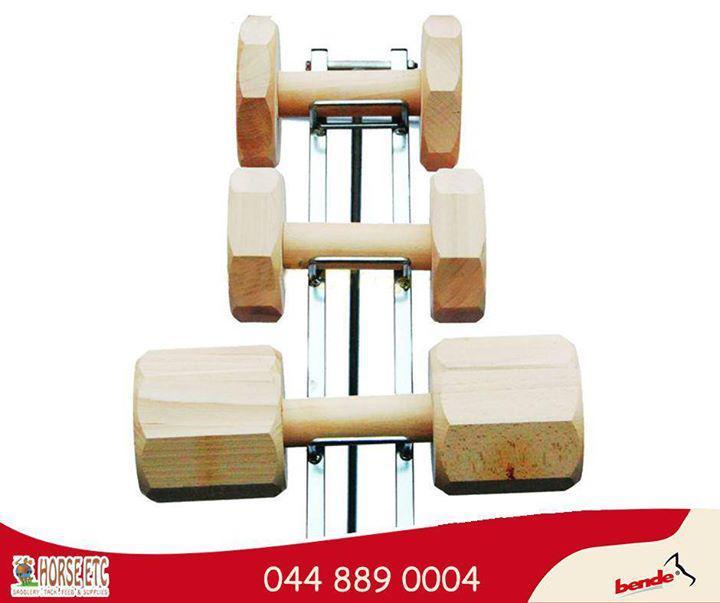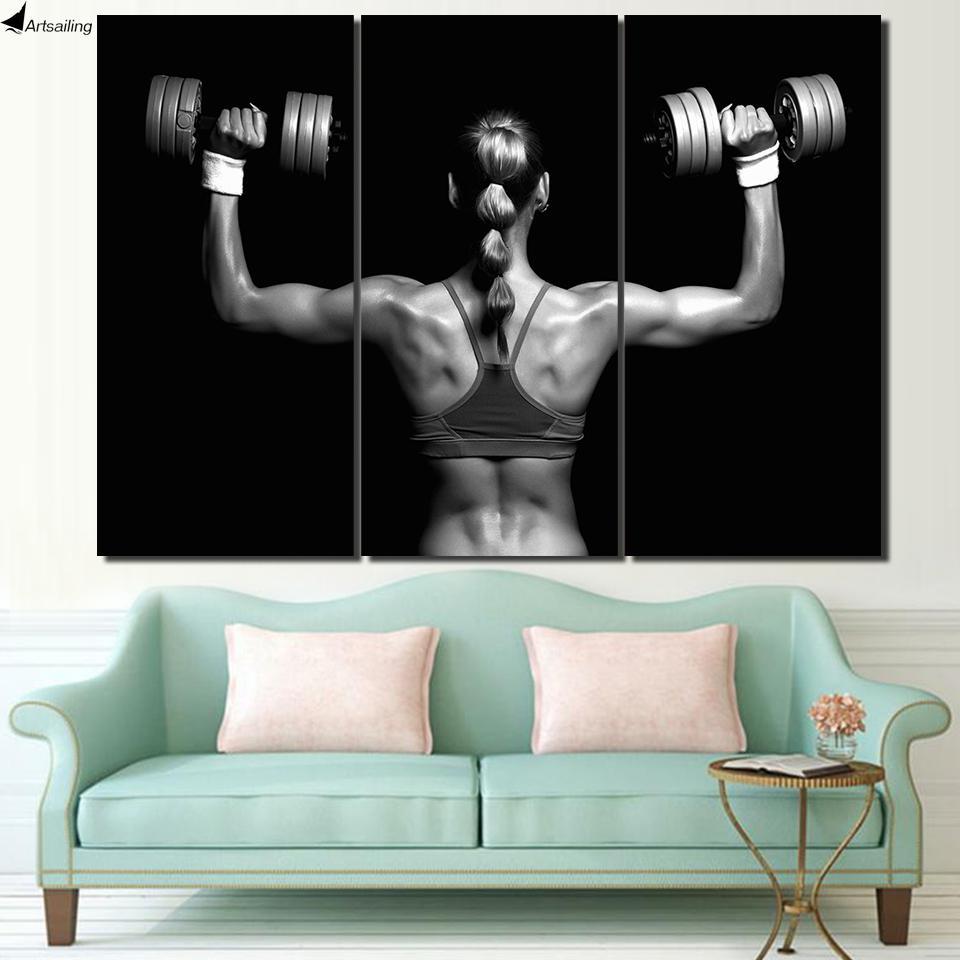The first image is the image on the left, the second image is the image on the right. Evaluate the accuracy of this statement regarding the images: "In one of the images there are three dumbbells of varying sizes arranged in a line.". Is it true? Answer yes or no. Yes. 